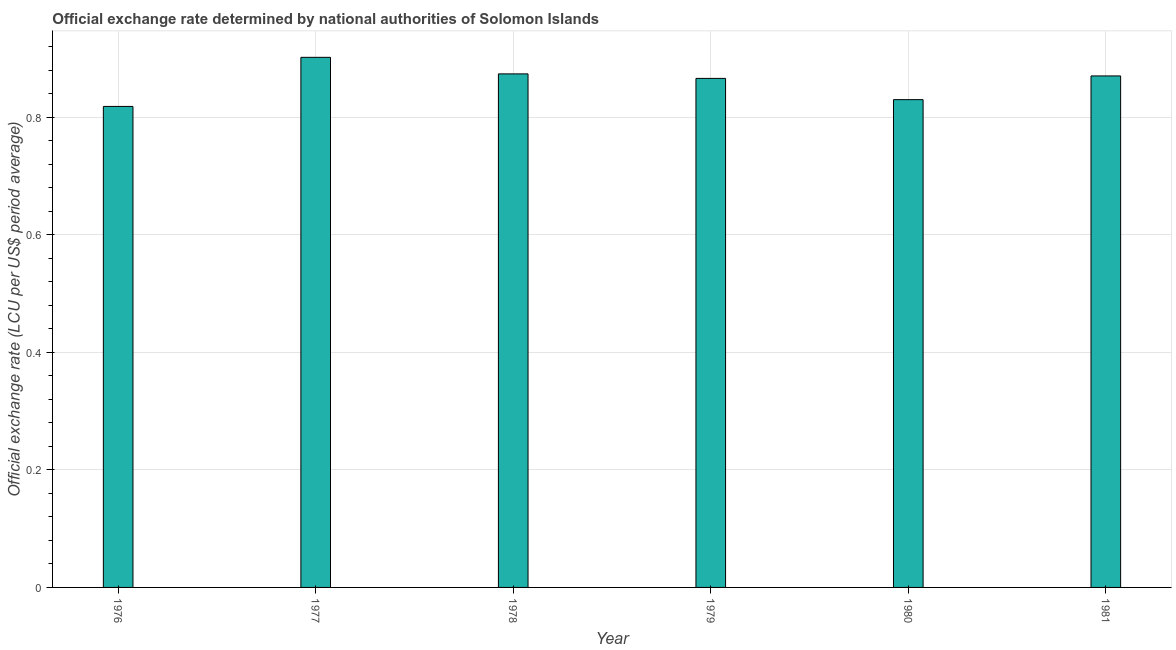Does the graph contain grids?
Ensure brevity in your answer.  Yes. What is the title of the graph?
Offer a very short reply. Official exchange rate determined by national authorities of Solomon Islands. What is the label or title of the X-axis?
Your answer should be compact. Year. What is the label or title of the Y-axis?
Your answer should be compact. Official exchange rate (LCU per US$ period average). What is the official exchange rate in 1980?
Your answer should be compact. 0.83. Across all years, what is the maximum official exchange rate?
Offer a very short reply. 0.9. Across all years, what is the minimum official exchange rate?
Make the answer very short. 0.82. In which year was the official exchange rate minimum?
Make the answer very short. 1976. What is the sum of the official exchange rate?
Your answer should be compact. 5.16. What is the difference between the official exchange rate in 1976 and 1981?
Give a very brief answer. -0.05. What is the average official exchange rate per year?
Offer a terse response. 0.86. What is the median official exchange rate?
Offer a very short reply. 0.87. Do a majority of the years between 1978 and 1981 (inclusive) have official exchange rate greater than 0.72 ?
Make the answer very short. Yes. What is the ratio of the official exchange rate in 1977 to that in 1980?
Ensure brevity in your answer.  1.09. Is the official exchange rate in 1976 less than that in 1979?
Offer a very short reply. Yes. Is the difference between the official exchange rate in 1978 and 1979 greater than the difference between any two years?
Provide a succinct answer. No. What is the difference between the highest and the second highest official exchange rate?
Give a very brief answer. 0.03. Is the sum of the official exchange rate in 1978 and 1979 greater than the maximum official exchange rate across all years?
Keep it short and to the point. Yes. Are the values on the major ticks of Y-axis written in scientific E-notation?
Keep it short and to the point. No. What is the Official exchange rate (LCU per US$ period average) of 1976?
Offer a very short reply. 0.82. What is the Official exchange rate (LCU per US$ period average) in 1977?
Provide a short and direct response. 0.9. What is the Official exchange rate (LCU per US$ period average) of 1978?
Your answer should be very brief. 0.87. What is the Official exchange rate (LCU per US$ period average) of 1979?
Offer a terse response. 0.87. What is the Official exchange rate (LCU per US$ period average) in 1980?
Provide a succinct answer. 0.83. What is the Official exchange rate (LCU per US$ period average) in 1981?
Provide a short and direct response. 0.87. What is the difference between the Official exchange rate (LCU per US$ period average) in 1976 and 1977?
Offer a terse response. -0.08. What is the difference between the Official exchange rate (LCU per US$ period average) in 1976 and 1978?
Offer a terse response. -0.06. What is the difference between the Official exchange rate (LCU per US$ period average) in 1976 and 1979?
Offer a terse response. -0.05. What is the difference between the Official exchange rate (LCU per US$ period average) in 1976 and 1980?
Give a very brief answer. -0.01. What is the difference between the Official exchange rate (LCU per US$ period average) in 1976 and 1981?
Your response must be concise. -0.05. What is the difference between the Official exchange rate (LCU per US$ period average) in 1977 and 1978?
Provide a short and direct response. 0.03. What is the difference between the Official exchange rate (LCU per US$ period average) in 1977 and 1979?
Your answer should be compact. 0.04. What is the difference between the Official exchange rate (LCU per US$ period average) in 1977 and 1980?
Provide a succinct answer. 0.07. What is the difference between the Official exchange rate (LCU per US$ period average) in 1977 and 1981?
Make the answer very short. 0.03. What is the difference between the Official exchange rate (LCU per US$ period average) in 1978 and 1979?
Offer a terse response. 0.01. What is the difference between the Official exchange rate (LCU per US$ period average) in 1978 and 1980?
Offer a very short reply. 0.04. What is the difference between the Official exchange rate (LCU per US$ period average) in 1978 and 1981?
Keep it short and to the point. 0. What is the difference between the Official exchange rate (LCU per US$ period average) in 1979 and 1980?
Ensure brevity in your answer.  0.04. What is the difference between the Official exchange rate (LCU per US$ period average) in 1979 and 1981?
Your response must be concise. -0. What is the difference between the Official exchange rate (LCU per US$ period average) in 1980 and 1981?
Your answer should be very brief. -0.04. What is the ratio of the Official exchange rate (LCU per US$ period average) in 1976 to that in 1977?
Give a very brief answer. 0.91. What is the ratio of the Official exchange rate (LCU per US$ period average) in 1976 to that in 1978?
Your answer should be very brief. 0.94. What is the ratio of the Official exchange rate (LCU per US$ period average) in 1976 to that in 1979?
Ensure brevity in your answer.  0.94. What is the ratio of the Official exchange rate (LCU per US$ period average) in 1976 to that in 1981?
Offer a very short reply. 0.94. What is the ratio of the Official exchange rate (LCU per US$ period average) in 1977 to that in 1978?
Your answer should be compact. 1.03. What is the ratio of the Official exchange rate (LCU per US$ period average) in 1977 to that in 1979?
Provide a short and direct response. 1.04. What is the ratio of the Official exchange rate (LCU per US$ period average) in 1977 to that in 1980?
Your answer should be compact. 1.09. What is the ratio of the Official exchange rate (LCU per US$ period average) in 1977 to that in 1981?
Your answer should be very brief. 1.04. What is the ratio of the Official exchange rate (LCU per US$ period average) in 1978 to that in 1980?
Ensure brevity in your answer.  1.05. What is the ratio of the Official exchange rate (LCU per US$ period average) in 1979 to that in 1980?
Give a very brief answer. 1.04. What is the ratio of the Official exchange rate (LCU per US$ period average) in 1979 to that in 1981?
Give a very brief answer. 0.99. What is the ratio of the Official exchange rate (LCU per US$ period average) in 1980 to that in 1981?
Give a very brief answer. 0.95. 